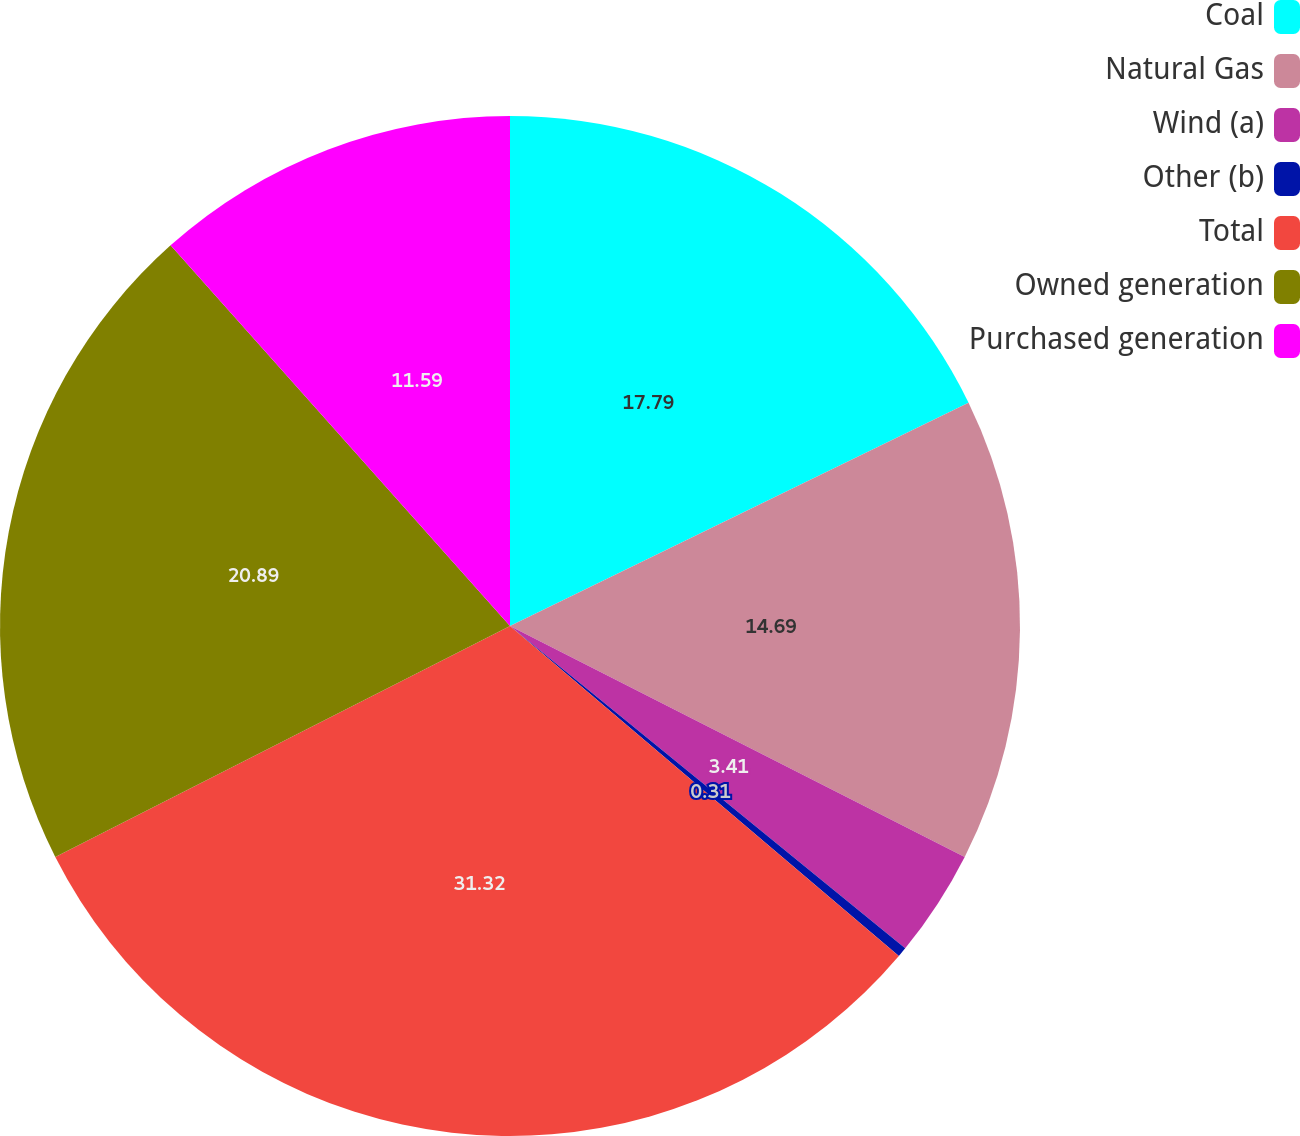Convert chart to OTSL. <chart><loc_0><loc_0><loc_500><loc_500><pie_chart><fcel>Coal<fcel>Natural Gas<fcel>Wind (a)<fcel>Other (b)<fcel>Total<fcel>Owned generation<fcel>Purchased generation<nl><fcel>17.79%<fcel>14.69%<fcel>3.41%<fcel>0.31%<fcel>31.32%<fcel>20.89%<fcel>11.59%<nl></chart> 